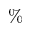<formula> <loc_0><loc_0><loc_500><loc_500>\%</formula> 